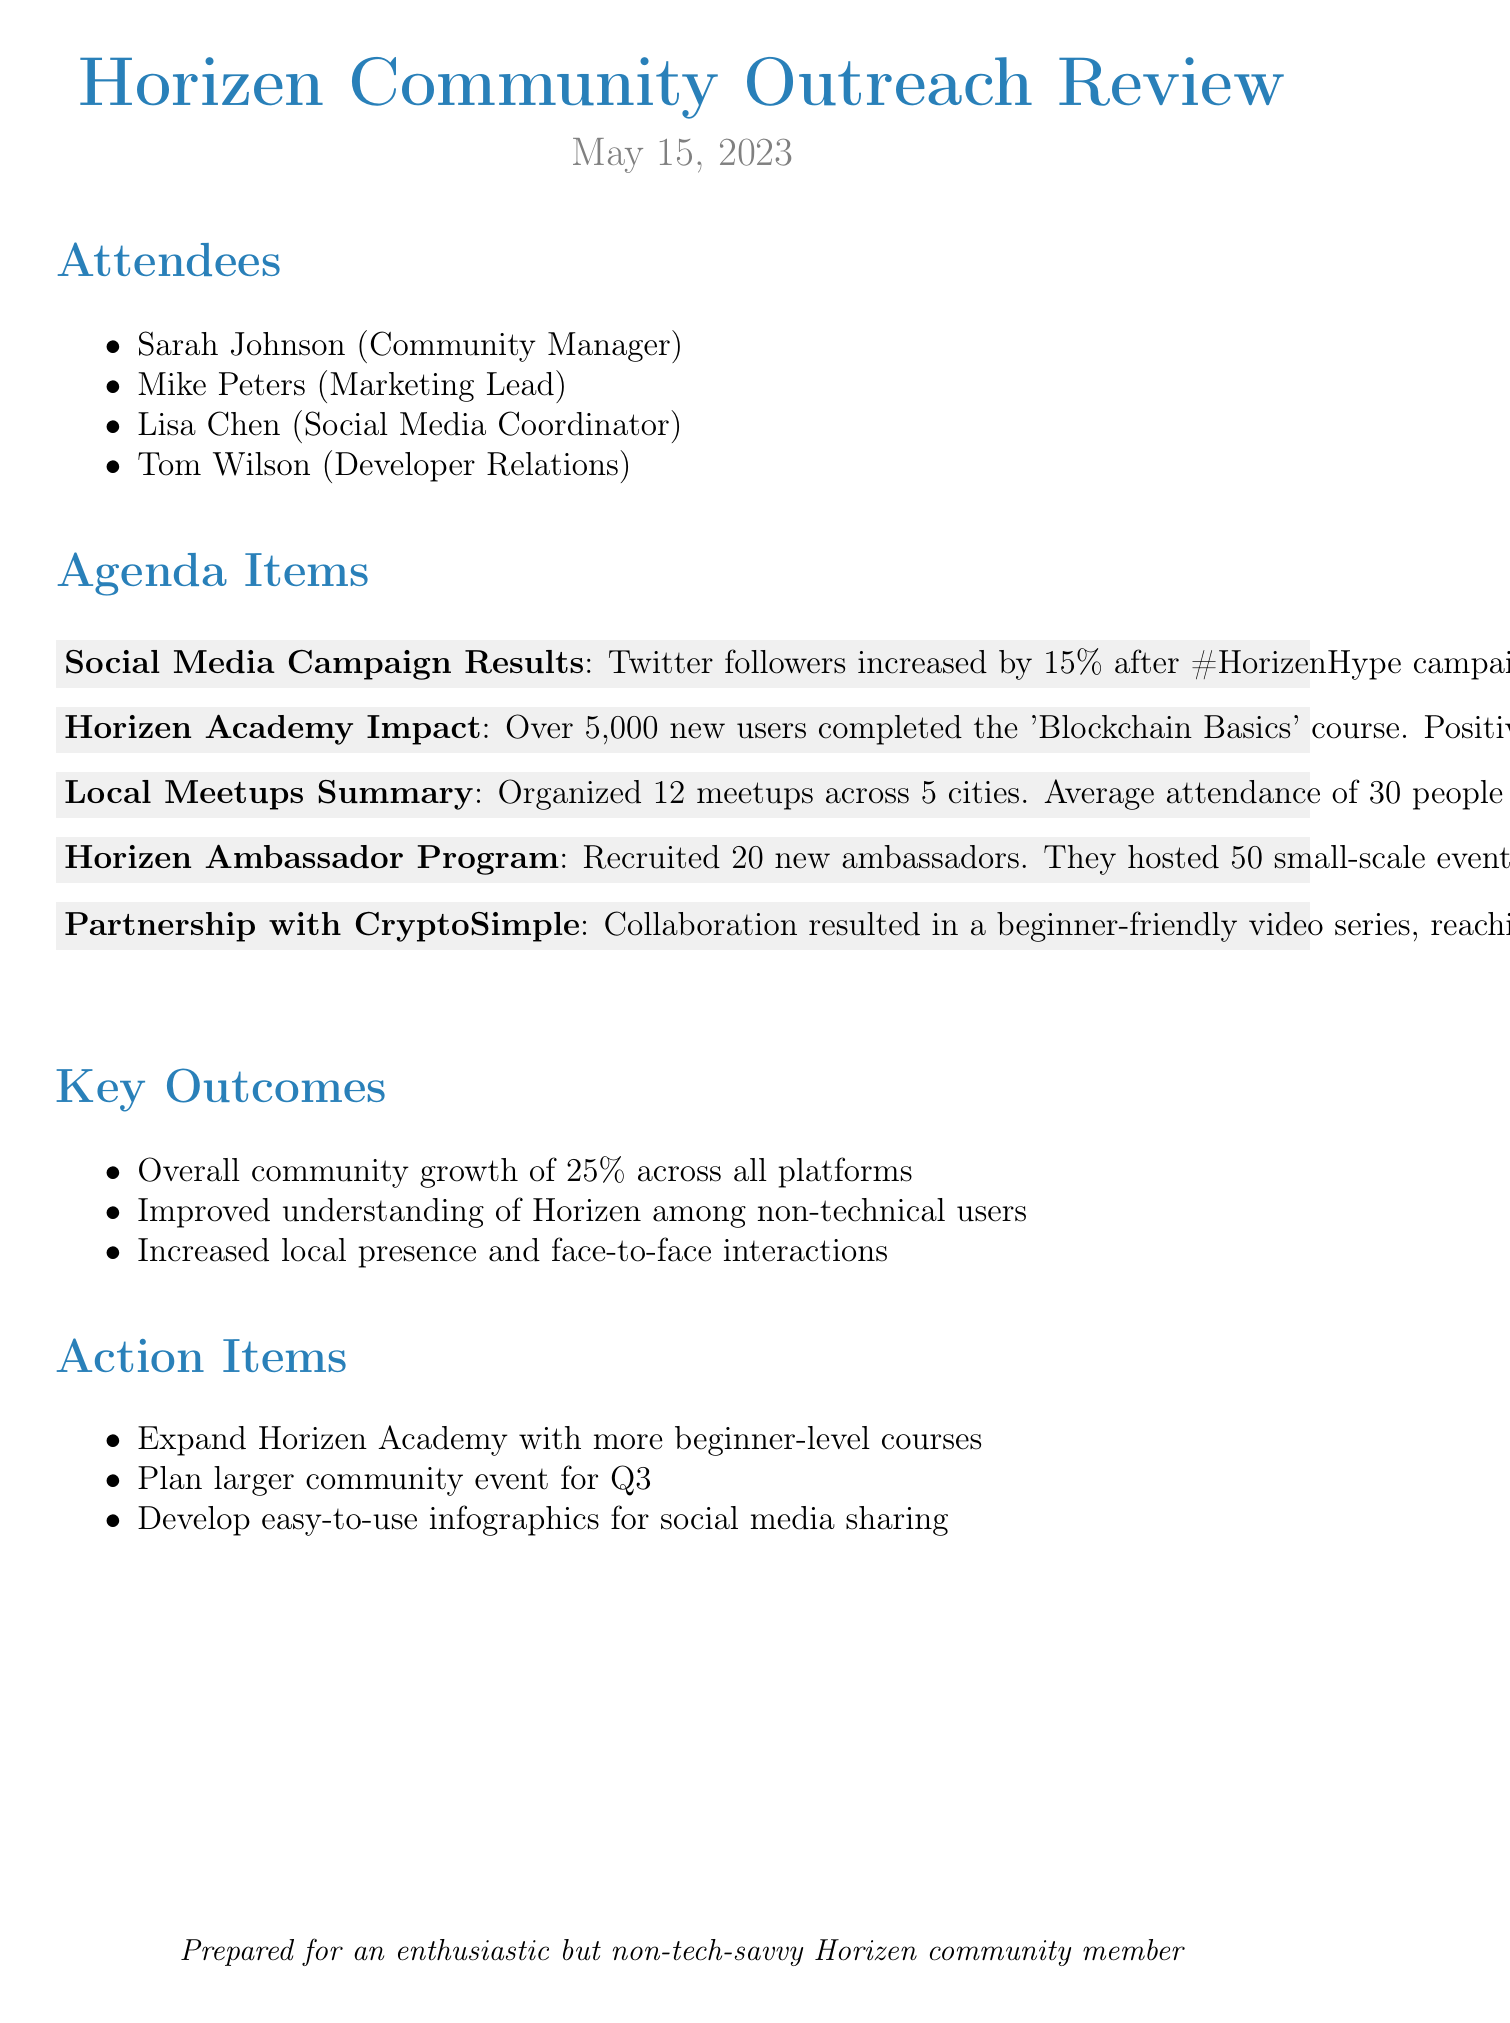What was the date of the meeting? The date of the meeting is explicitly mentioned in the document as May 15, 2023.
Answer: May 15, 2023 How many attendees were present? The number of attendees can be counted from the list provided, which includes four names.
Answer: 4 What was the percentage increase in Twitter followers? The document states that Twitter followers increased by 15% after the campaign.
Answer: 15% How many new users completed the 'Blockchain Basics' course? The document specifies that over 5,000 new users completed the course.
Answer: Over 5,000 What was the average attendance for the local meetups? Average attendance is detailed in the summary of local meetups as 30 people per event.
Answer: 30 What was a key outcome of the community outreach initiatives? The document lists several outcomes, including overall community growth of 25%.
Answer: 25% How many ambassadors were recruited? The number of new ambassadors recruited is clearly stated as 20.
Answer: 20 What action item involves expanding educational resources? The document mentions the action item to expand Horizen Academy with more beginner-level courses.
Answer: Expand Horizen Academy with more beginner-level courses What type of content was created as a result of the partnership with CryptoSimple? The collaboration resulted in a beginner-friendly video series.
Answer: Beginner-friendly video series 